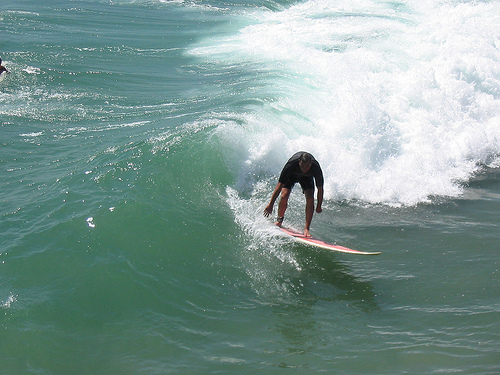Please provide the bounding box coordinate of the region this sentence describes: this is a wave. The bounding box for the wave region is [0.52, 0.39, 0.77, 0.49]. The wave can be seen curling just in front of the surfer. 